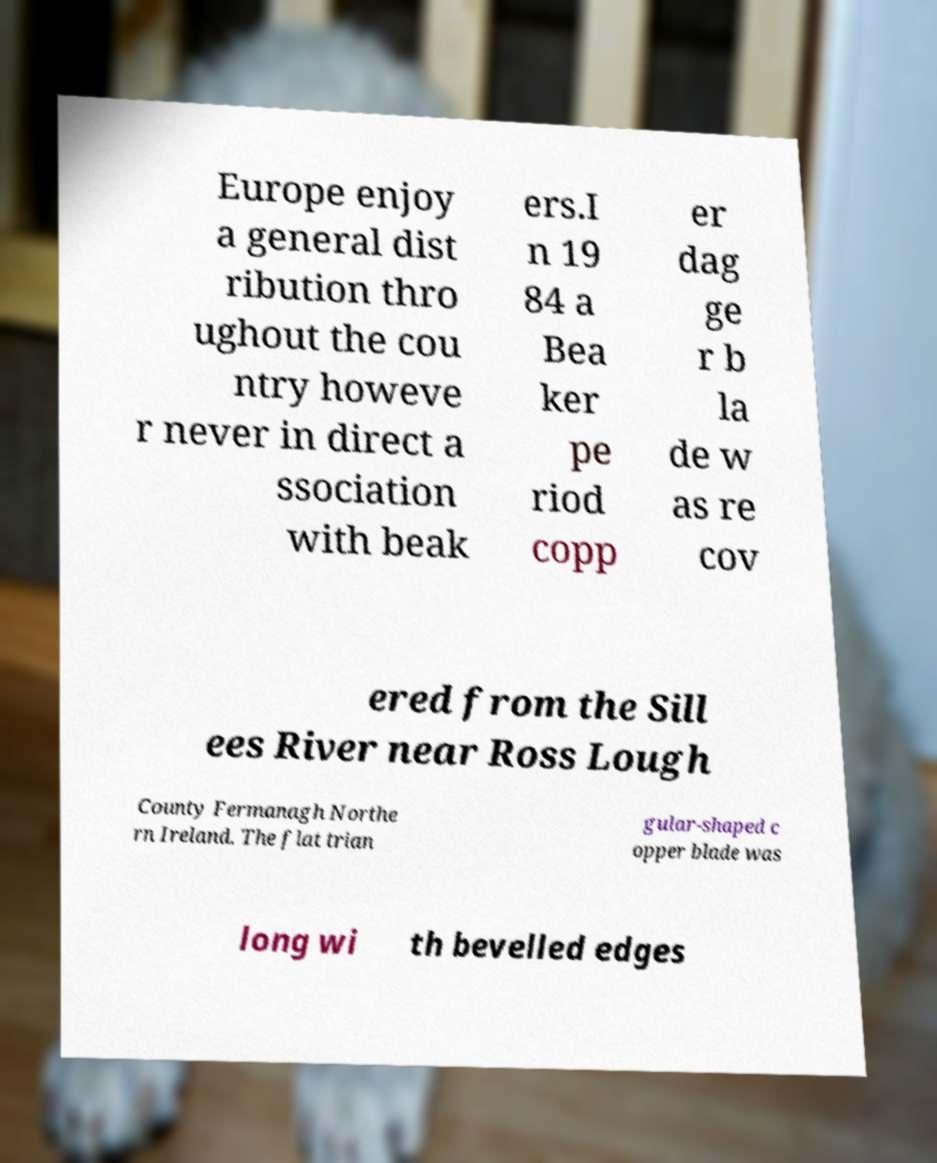Can you read and provide the text displayed in the image?This photo seems to have some interesting text. Can you extract and type it out for me? Europe enjoy a general dist ribution thro ughout the cou ntry howeve r never in direct a ssociation with beak ers.I n 19 84 a Bea ker pe riod copp er dag ge r b la de w as re cov ered from the Sill ees River near Ross Lough County Fermanagh Northe rn Ireland. The flat trian gular-shaped c opper blade was long wi th bevelled edges 